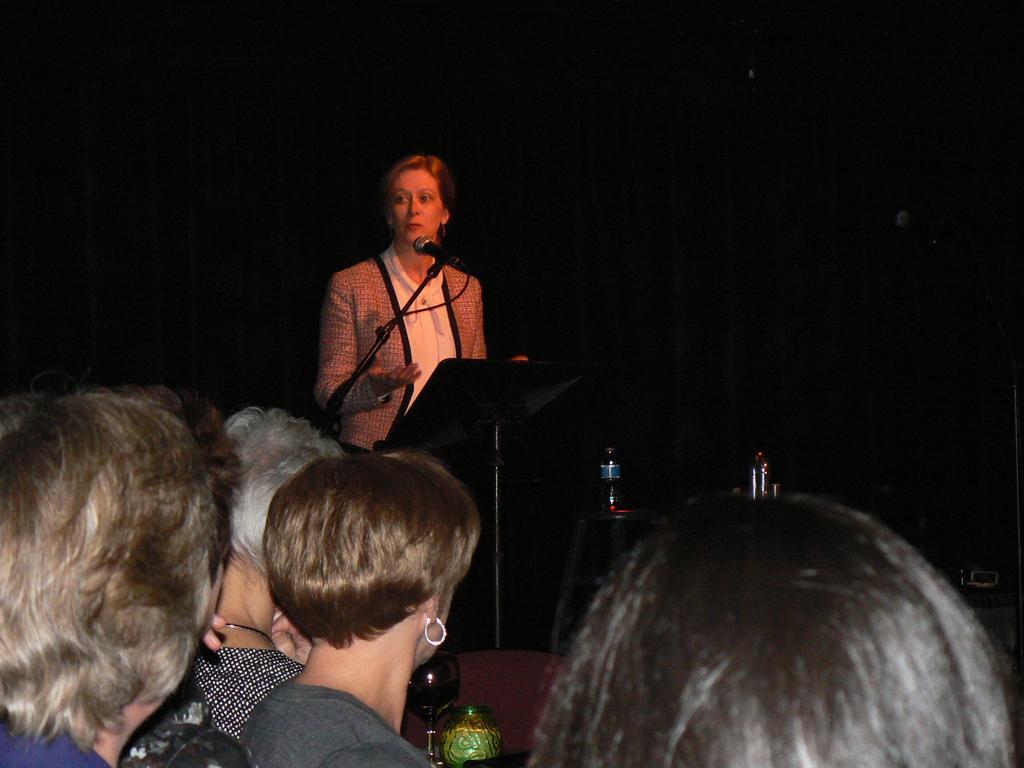How would you summarize this image in a sentence or two? In this image, there are a few people. We can see a stand, a microphone and some objects like bottles and a glass. We can also see the dark background. 